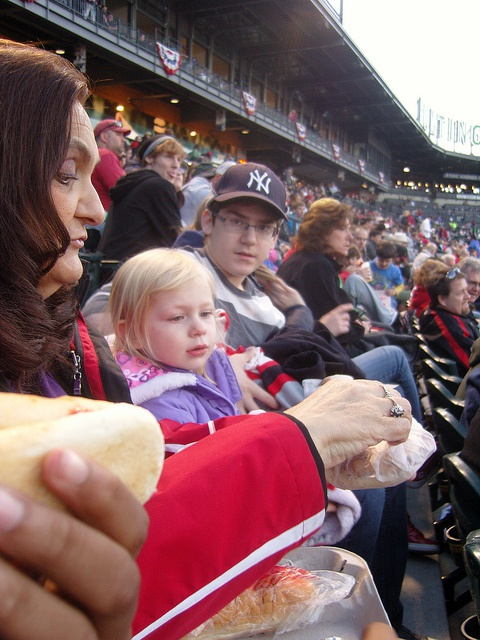Describe the objects in this image and their specific colors. I can see people in black, brown, and maroon tones, people in black, gray, and darkgray tones, people in black, brown, lightgray, lightpink, and violet tones, hot dog in black, beige, tan, and gray tones, and people in black and gray tones in this image. 